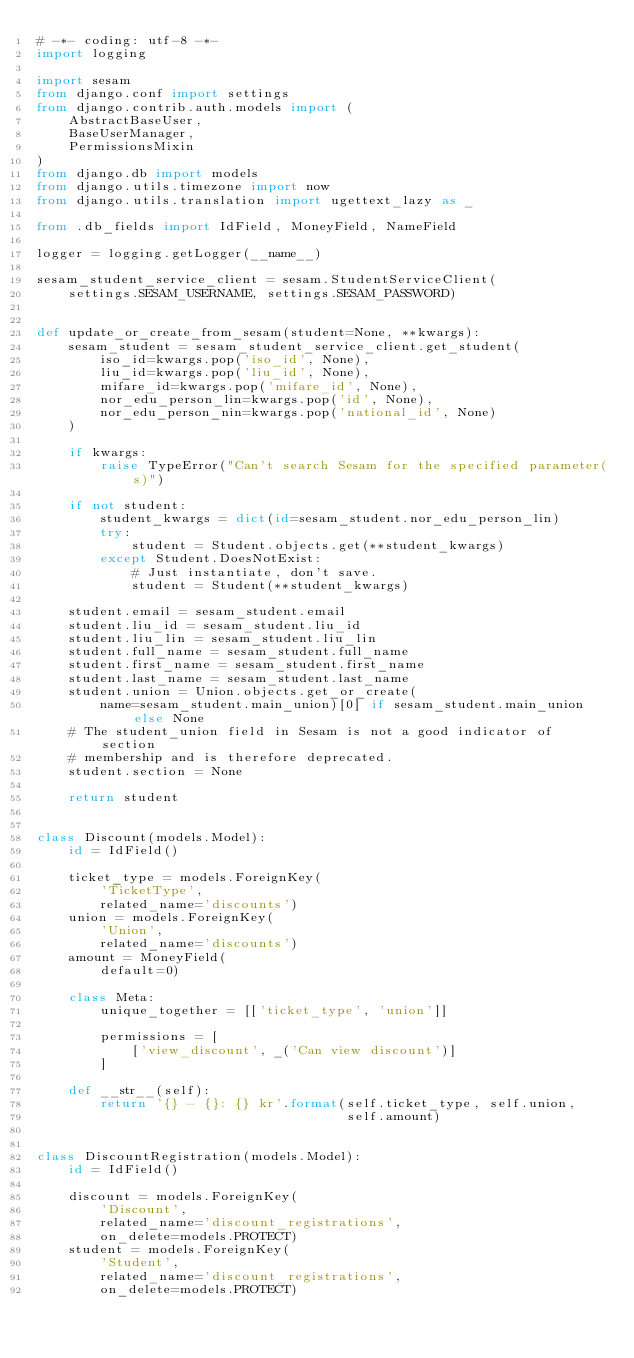<code> <loc_0><loc_0><loc_500><loc_500><_Python_># -*- coding: utf-8 -*-
import logging

import sesam
from django.conf import settings
from django.contrib.auth.models import (
    AbstractBaseUser,
    BaseUserManager,
    PermissionsMixin
)
from django.db import models
from django.utils.timezone import now
from django.utils.translation import ugettext_lazy as _

from .db_fields import IdField, MoneyField, NameField

logger = logging.getLogger(__name__)

sesam_student_service_client = sesam.StudentServiceClient(
    settings.SESAM_USERNAME, settings.SESAM_PASSWORD)


def update_or_create_from_sesam(student=None, **kwargs):
    sesam_student = sesam_student_service_client.get_student(
        iso_id=kwargs.pop('iso_id', None),
        liu_id=kwargs.pop('liu_id', None),
        mifare_id=kwargs.pop('mifare_id', None),
        nor_edu_person_lin=kwargs.pop('id', None),
        nor_edu_person_nin=kwargs.pop('national_id', None)
    )

    if kwargs:
        raise TypeError("Can't search Sesam for the specified parameter(s)")

    if not student:
        student_kwargs = dict(id=sesam_student.nor_edu_person_lin)
        try:
            student = Student.objects.get(**student_kwargs)
        except Student.DoesNotExist:
            # Just instantiate, don't save.
            student = Student(**student_kwargs)

    student.email = sesam_student.email
    student.liu_id = sesam_student.liu_id
    student.liu_lin = sesam_student.liu_lin
    student.full_name = sesam_student.full_name
    student.first_name = sesam_student.first_name
    student.last_name = sesam_student.last_name
    student.union = Union.objects.get_or_create(
        name=sesam_student.main_union)[0] if sesam_student.main_union else None
    # The student_union field in Sesam is not a good indicator of section
    # membership and is therefore deprecated.
    student.section = None

    return student


class Discount(models.Model):
    id = IdField()

    ticket_type = models.ForeignKey(
        'TicketType',
        related_name='discounts')
    union = models.ForeignKey(
        'Union',
        related_name='discounts')
    amount = MoneyField(
        default=0)

    class Meta:
        unique_together = [['ticket_type', 'union']]

        permissions = [
            ['view_discount', _('Can view discount')]
        ]

    def __str__(self):
        return '{} - {}: {} kr'.format(self.ticket_type, self.union,
                                       self.amount)


class DiscountRegistration(models.Model):
    id = IdField()

    discount = models.ForeignKey(
        'Discount',
        related_name='discount_registrations',
        on_delete=models.PROTECT)
    student = models.ForeignKey(
        'Student',
        related_name='discount_registrations',
        on_delete=models.PROTECT)
</code> 